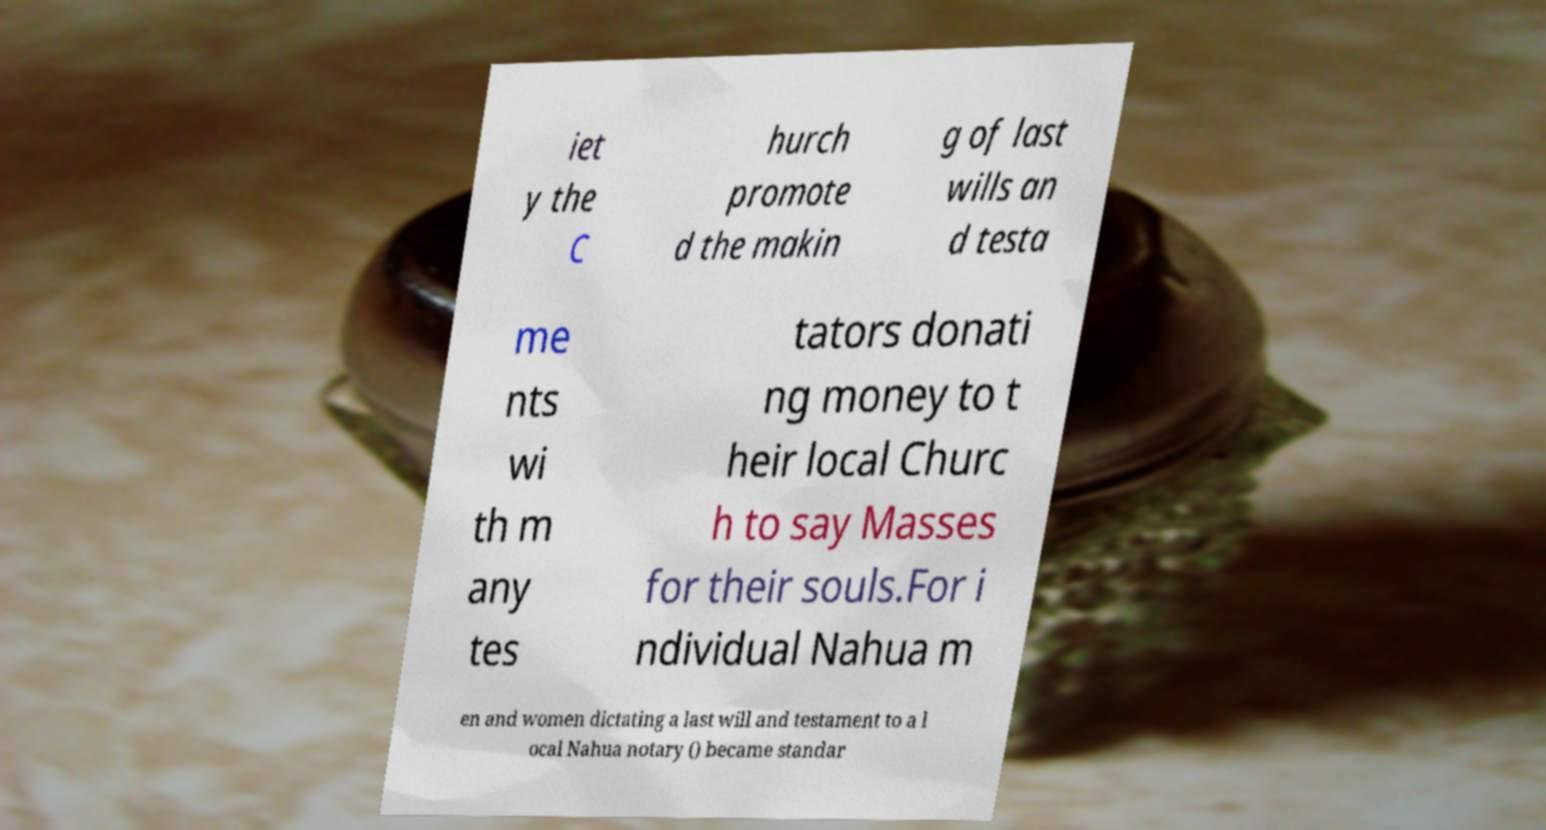Could you assist in decoding the text presented in this image and type it out clearly? iet y the C hurch promote d the makin g of last wills an d testa me nts wi th m any tes tators donati ng money to t heir local Churc h to say Masses for their souls.For i ndividual Nahua m en and women dictating a last will and testament to a l ocal Nahua notary () became standar 